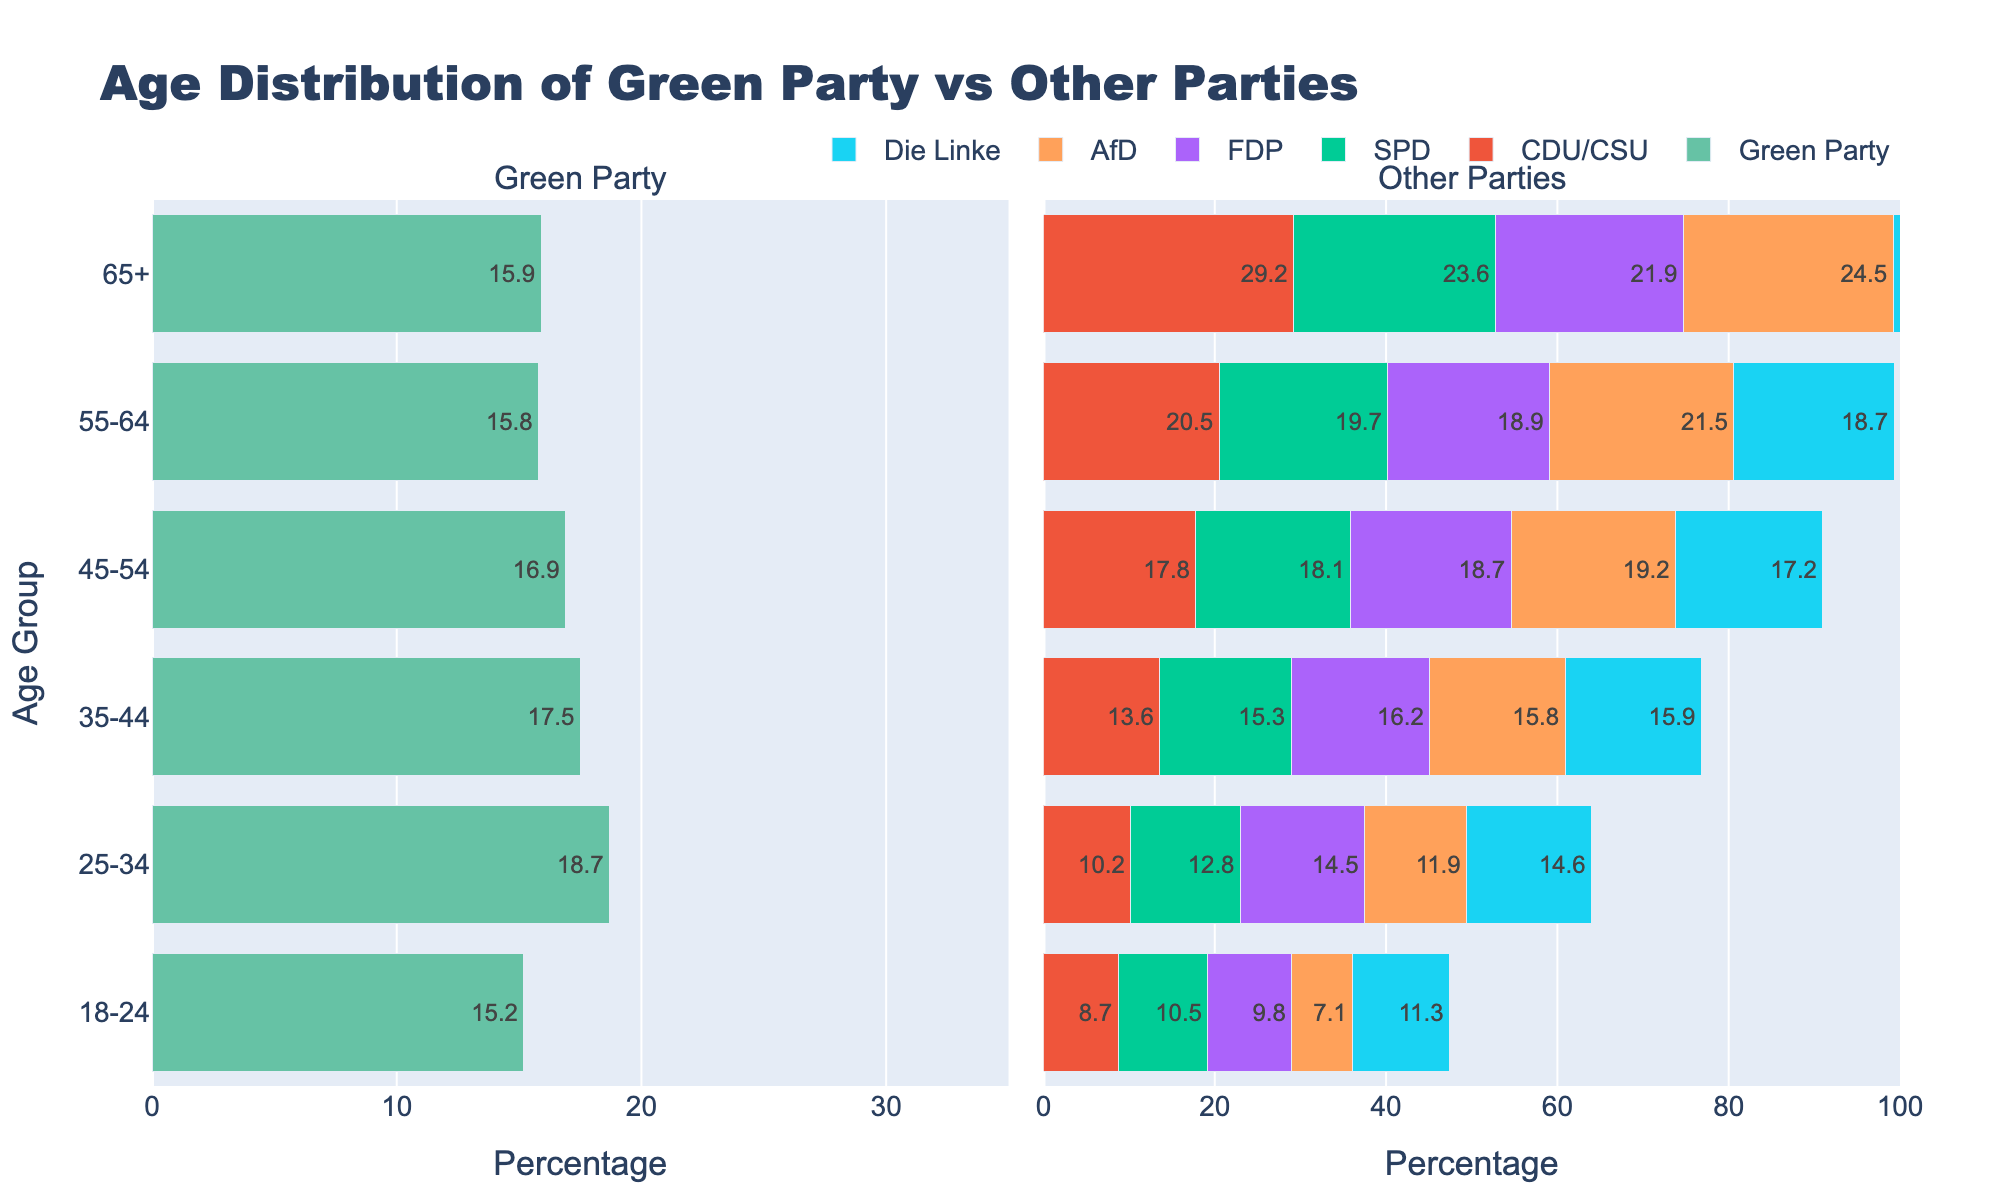What is the title of the figure? The title can be found at the top of the figure. It reads "Age Distribution of Green Party vs Other Parties".
Answer: Age Distribution of Green Party vs Other Parties Which age group has the highest percentage of Green Party voters? By looking at the Green Party bars on the left side, the 25-34 age group has the longest bar, indicating the highest percentage.
Answer: 25-34 How does the percentage of voters aged 65+ for the Green Party compare to the CDU/CSU? Compare the length of the bars for the 65+ age group. The Green Party has around 15.9%, while CDU/CSU has 29.2%, making CDU/CSU significantly higher.
Answer: CDU/CSU has a higher percentage Which age group shows the closest percentage between Green Party and Die Linke voters? For each age group, observe the proximity of the bar lengths for Green Party and Die Linke. The 35-44 and 65+ age groups have very close percentages.
Answer: 35-44 and 65+ Combine the percentages of Green Party voters aged 18-24 and 25-34. What is the total? Add the percentages of the 18-24 and 25-34 age groups for the Green Party: 15.2% + 18.7% = 33.9%.
Answer: 33.9% What is the average percentage of Green Party voters across all age groups? Sum all percentages for Green Party and divide by the number of age groups: (15.2 + 18.7 + 17.5 + 16.9 + 15.8 + 15.9)/6 = 16.67%.
Answer: 16.67% Which age group has the highest percentage difference between Green Party and SPD voters? Calculate the percentage difference for each age group and compare. The 65+ age group shows the highest difference (23.6% - 15.9% = 7.7%).
Answer: 65+ What is the sum of percentages for the 35-44 age group across all parties? Sum the percentages for all parties in the 35-44 age group: 17.5 + 13.6 + 15.3 + 16.2 + 15.8 + 15.9 = 94.3%.
Answer: 94.3% Which party has the most even distribution of voter percentages across all age groups, and what range do these percentages fall within? Determine the party with the smallest range (max - min percentage). The Green Party's percentages fall between 15.2% and 18.7%, resulting in a range of 3.5%.
Answer: Green Party, range 3.5% 